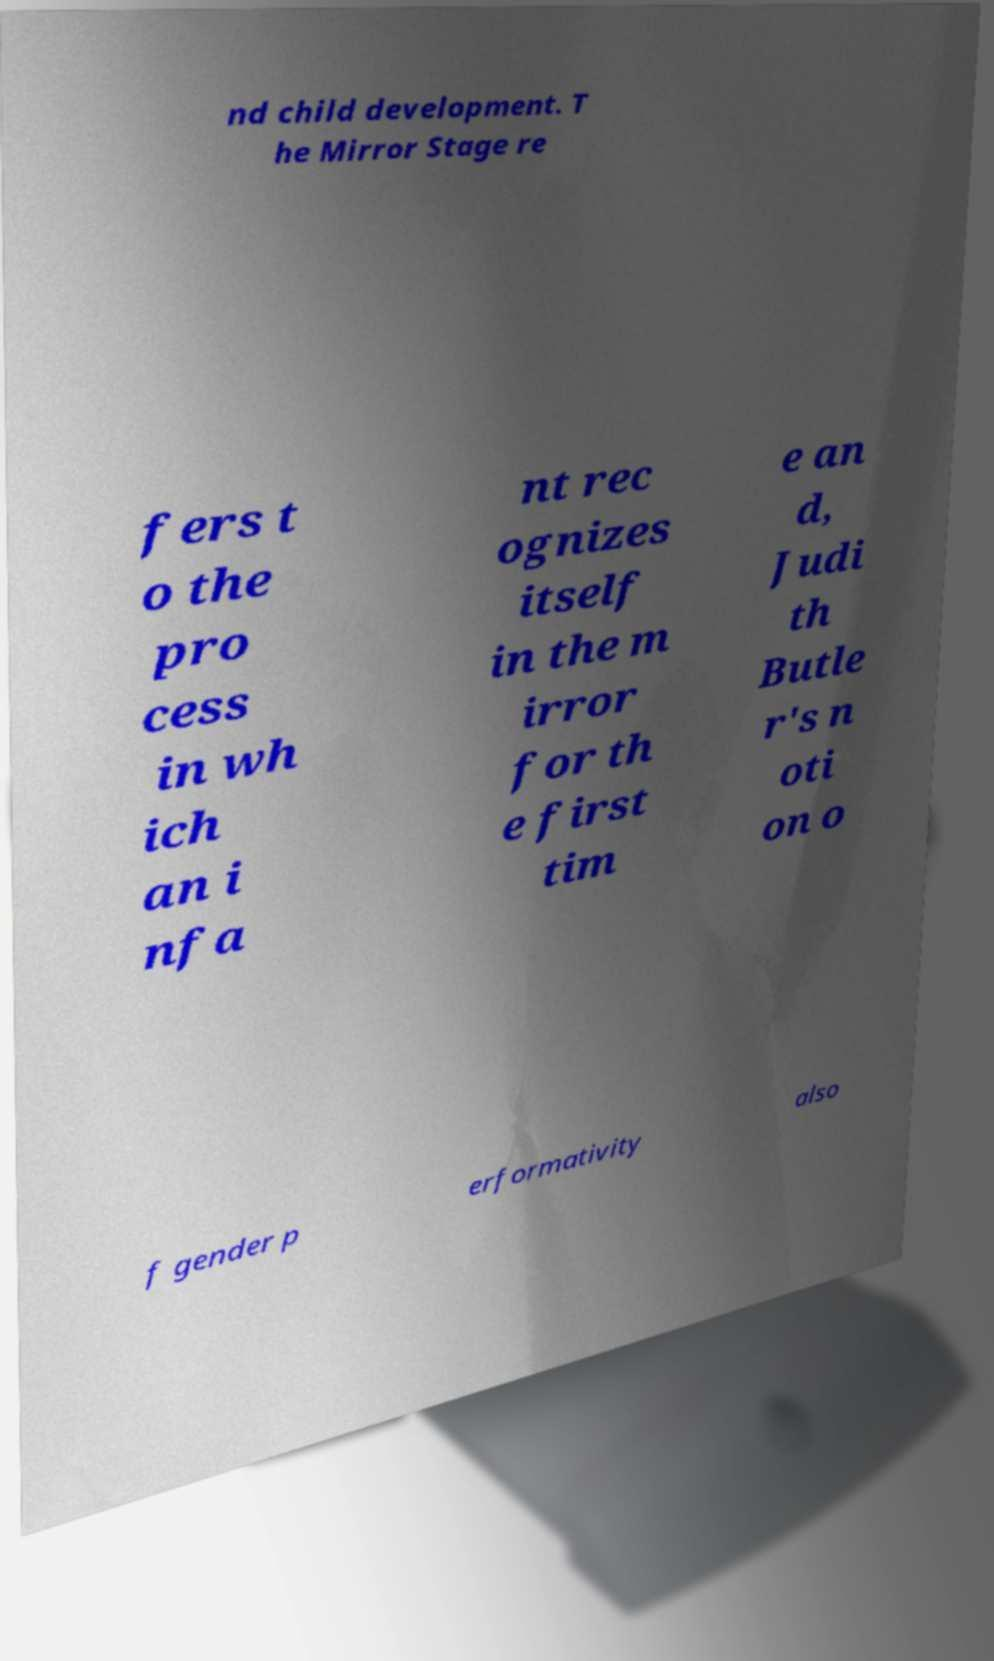Please identify and transcribe the text found in this image. nd child development. T he Mirror Stage re fers t o the pro cess in wh ich an i nfa nt rec ognizes itself in the m irror for th e first tim e an d, Judi th Butle r's n oti on o f gender p erformativity also 